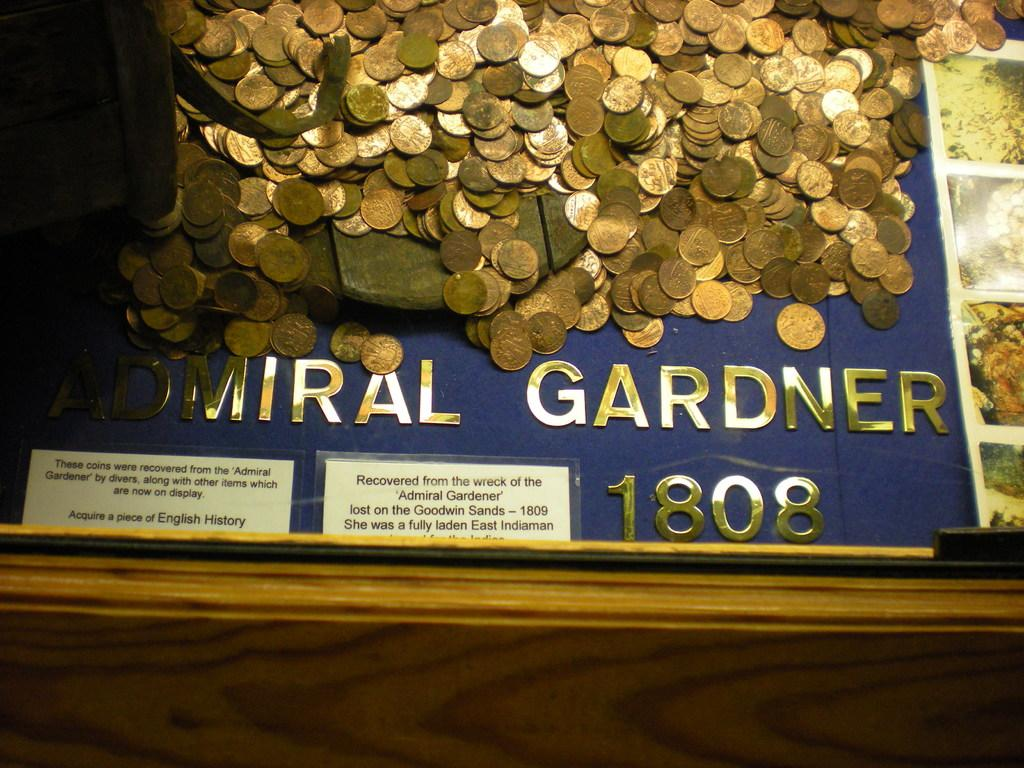<image>
Summarize the visual content of the image. A shelf full of pennies with Admiral Gerdner 1808 written on it. 